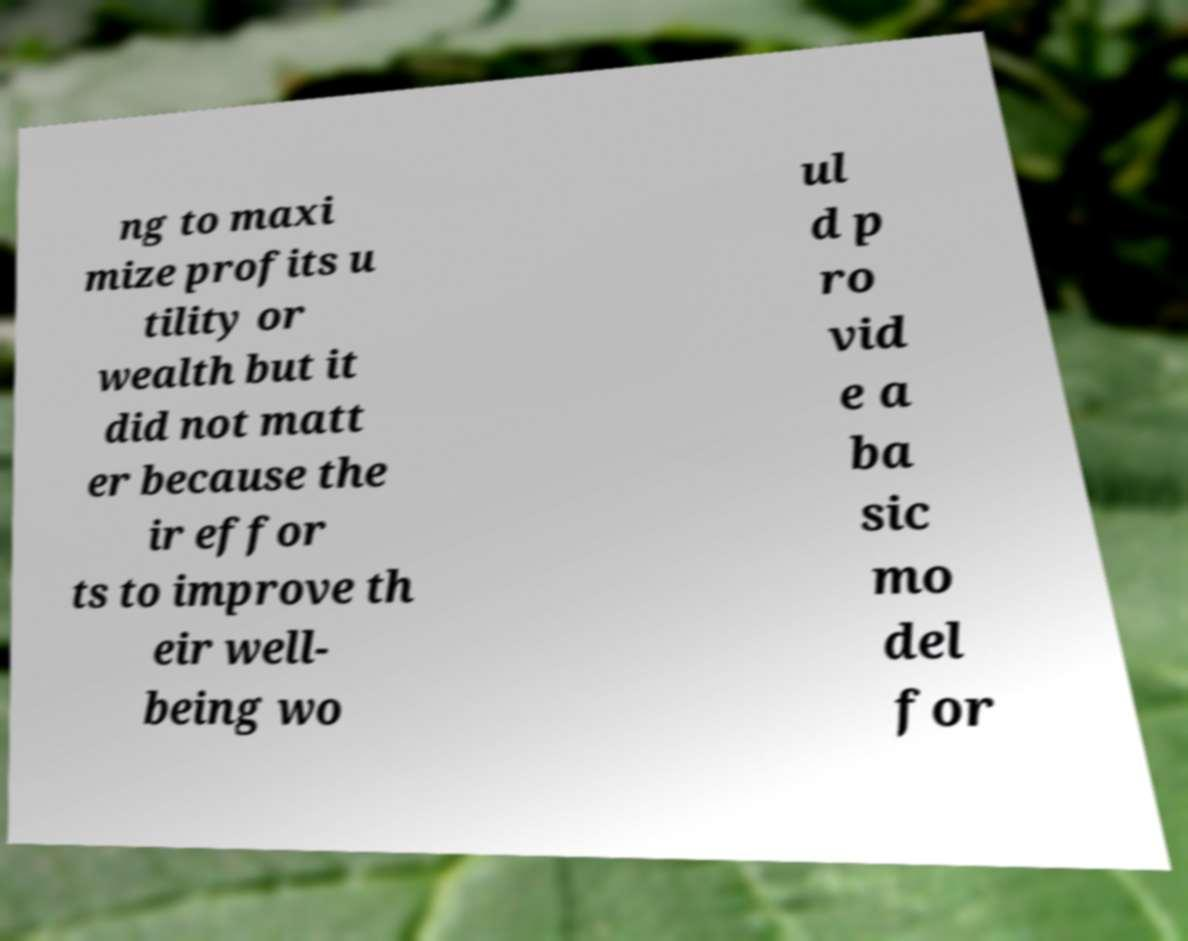Please identify and transcribe the text found in this image. ng to maxi mize profits u tility or wealth but it did not matt er because the ir effor ts to improve th eir well- being wo ul d p ro vid e a ba sic mo del for 